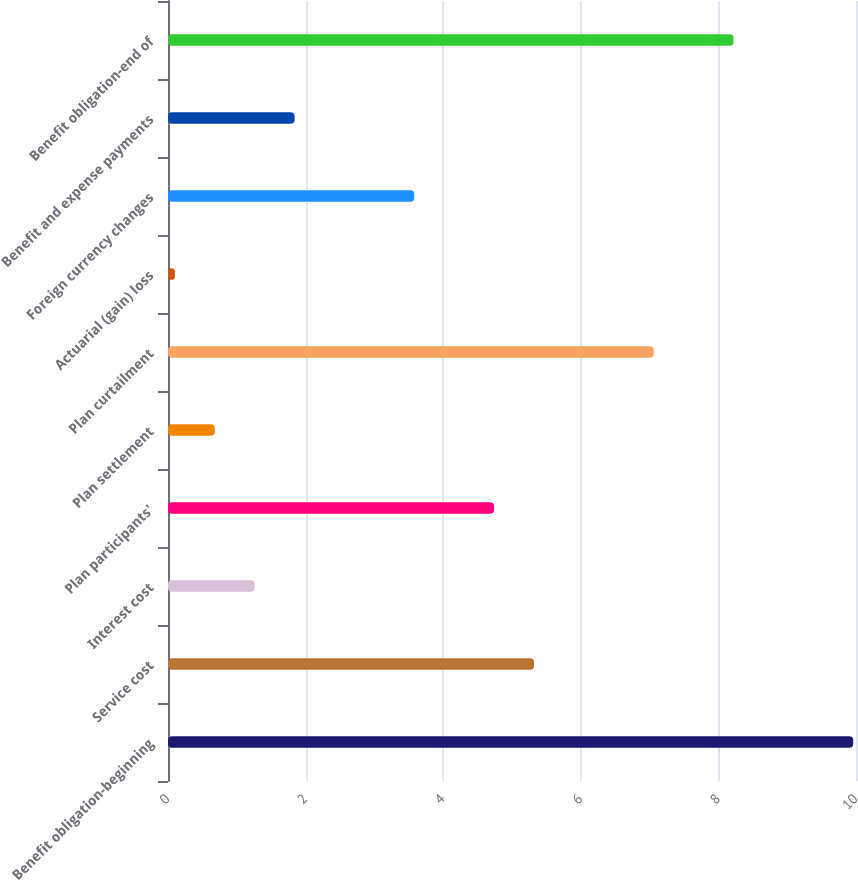Convert chart. <chart><loc_0><loc_0><loc_500><loc_500><bar_chart><fcel>Benefit obligation-beginning<fcel>Service cost<fcel>Interest cost<fcel>Plan participants'<fcel>Plan settlement<fcel>Plan curtailment<fcel>Actuarial (gain) loss<fcel>Foreign currency changes<fcel>Benefit and expense payments<fcel>Benefit obligation-end of<nl><fcel>9.96<fcel>5.32<fcel>1.26<fcel>4.74<fcel>0.68<fcel>7.06<fcel>0.1<fcel>3.58<fcel>1.84<fcel>8.22<nl></chart> 